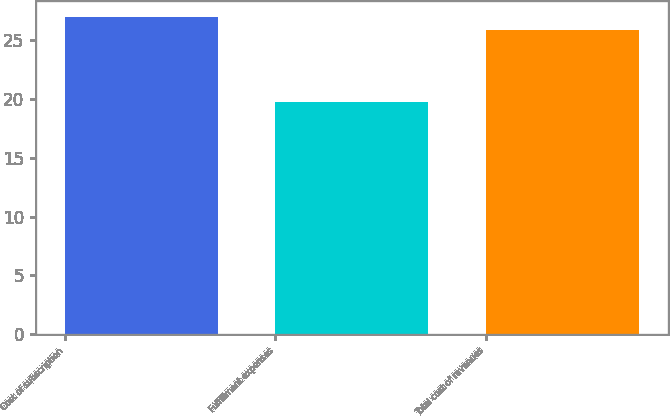<chart> <loc_0><loc_0><loc_500><loc_500><bar_chart><fcel>Cost of subscription<fcel>Fulfillment expenses<fcel>Total cost of revenues<nl><fcel>26.9<fcel>19.7<fcel>25.8<nl></chart> 